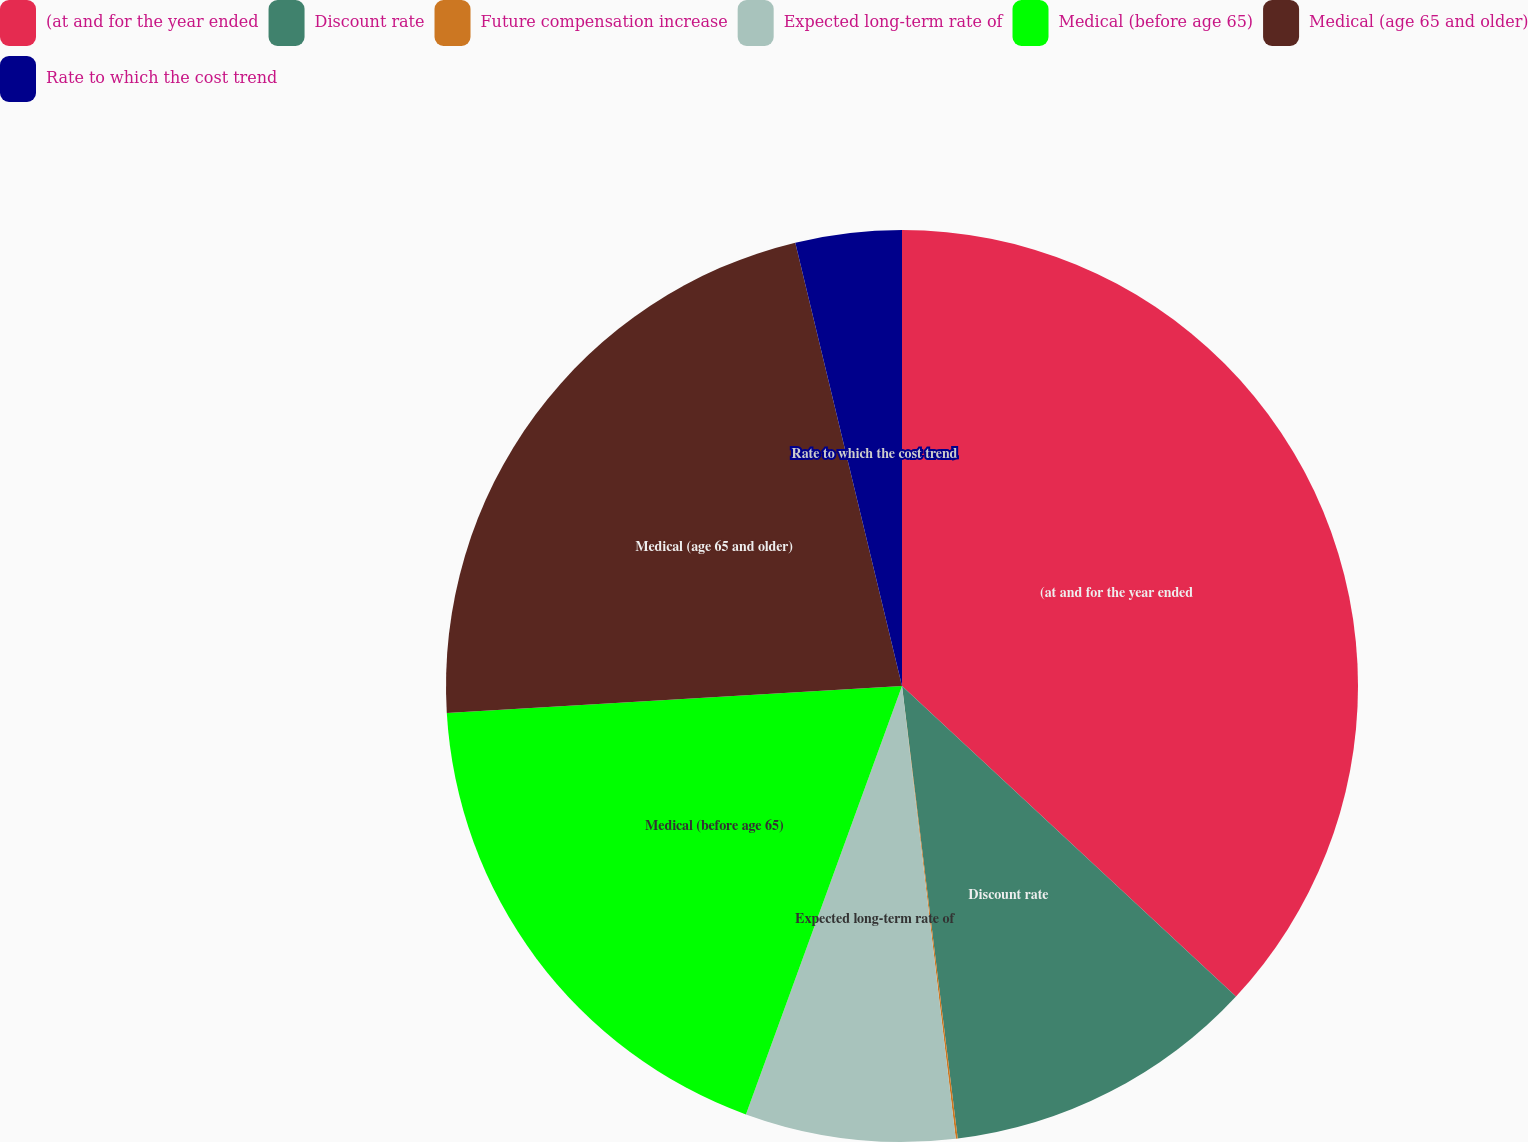Convert chart to OTSL. <chart><loc_0><loc_0><loc_500><loc_500><pie_chart><fcel>(at and for the year ended<fcel>Discount rate<fcel>Future compensation increase<fcel>Expected long-term rate of<fcel>Medical (before age 65)<fcel>Medical (age 65 and older)<fcel>Rate to which the cost trend<nl><fcel>36.92%<fcel>11.13%<fcel>0.07%<fcel>7.44%<fcel>18.5%<fcel>22.18%<fcel>3.76%<nl></chart> 